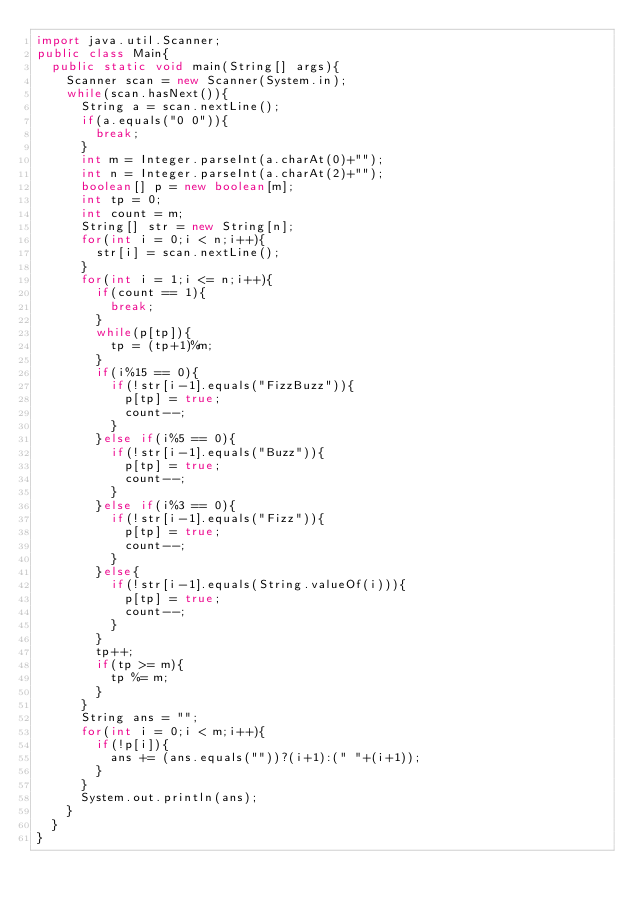<code> <loc_0><loc_0><loc_500><loc_500><_Java_>import java.util.Scanner;
public class Main{
	public static void main(String[] args){
		Scanner scan = new Scanner(System.in);
		while(scan.hasNext()){
			String a = scan.nextLine();
			if(a.equals("0 0")){
				break;
			}
			int m = Integer.parseInt(a.charAt(0)+"");
			int n = Integer.parseInt(a.charAt(2)+"");
			boolean[] p = new boolean[m];
			int tp = 0;
			int count = m;
			String[] str = new String[n];
			for(int i = 0;i < n;i++){
				str[i] = scan.nextLine();
			}
			for(int i = 1;i <= n;i++){
				if(count == 1){
					break;
				}
				while(p[tp]){
					tp = (tp+1)%m;
				}
				if(i%15 == 0){
					if(!str[i-1].equals("FizzBuzz")){
						p[tp] = true;
						count--;
					}
				}else if(i%5 == 0){
					if(!str[i-1].equals("Buzz")){
						p[tp] = true;
						count--;
					}
				}else if(i%3 == 0){
					if(!str[i-1].equals("Fizz")){
						p[tp] = true;
						count--;
					}
				}else{
					if(!str[i-1].equals(String.valueOf(i))){
						p[tp] = true;
						count--;
					}
				}
				tp++;
				if(tp >= m){
					tp %= m;
				}
			}
			String ans = "";
			for(int i = 0;i < m;i++){
				if(!p[i]){
					ans += (ans.equals(""))?(i+1):(" "+(i+1));
				}
			}
			System.out.println(ans);
		}
	}
}</code> 